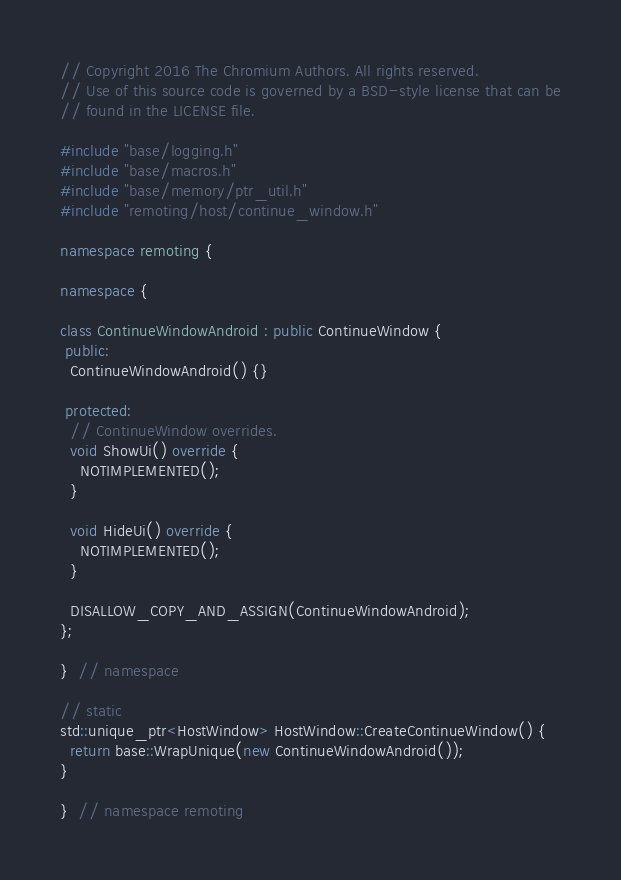Convert code to text. <code><loc_0><loc_0><loc_500><loc_500><_C++_>// Copyright 2016 The Chromium Authors. All rights reserved.
// Use of this source code is governed by a BSD-style license that can be
// found in the LICENSE file.

#include "base/logging.h"
#include "base/macros.h"
#include "base/memory/ptr_util.h"
#include "remoting/host/continue_window.h"

namespace remoting {

namespace {

class ContinueWindowAndroid : public ContinueWindow {
 public:
  ContinueWindowAndroid() {}

 protected:
  // ContinueWindow overrides.
  void ShowUi() override {
    NOTIMPLEMENTED();
  }

  void HideUi() override {
    NOTIMPLEMENTED();
  }

  DISALLOW_COPY_AND_ASSIGN(ContinueWindowAndroid);
};

}  // namespace

// static
std::unique_ptr<HostWindow> HostWindow::CreateContinueWindow() {
  return base::WrapUnique(new ContinueWindowAndroid());
}

}  // namespace remoting
</code> 